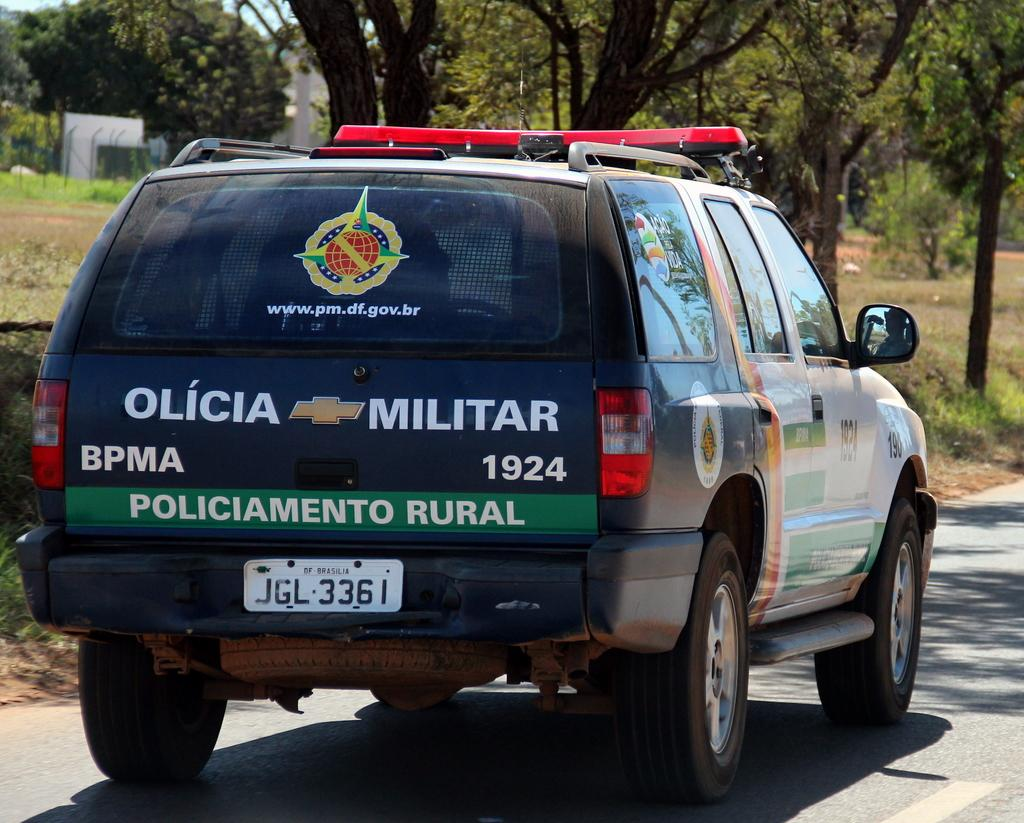What type of vehicle can be seen on the road in the image? There is a car on the road in the image. What type of vegetation is visible in the image? Grass is visible in the image, and there is a group of trees present as well. What type of material is the fence made of in the image? The fence in the image is made of metal. What type of structure can be seen in the image? There is a building in the image. What part of the natural environment is visible in the image? The bark of trees and the sky are visible in the image. What type of rock is being used as a paperweight on the desk in the image? There is no desk or paperweight present in the image; it features a car on the road, grass, trees, a metal fence, a building, and the sky. 